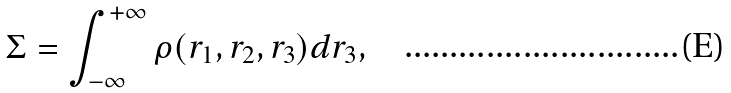<formula> <loc_0><loc_0><loc_500><loc_500>\Sigma = \int _ { - \infty } ^ { + \infty } \rho ( r _ { 1 } , r _ { 2 } , r _ { 3 } ) d r _ { 3 } ,</formula> 